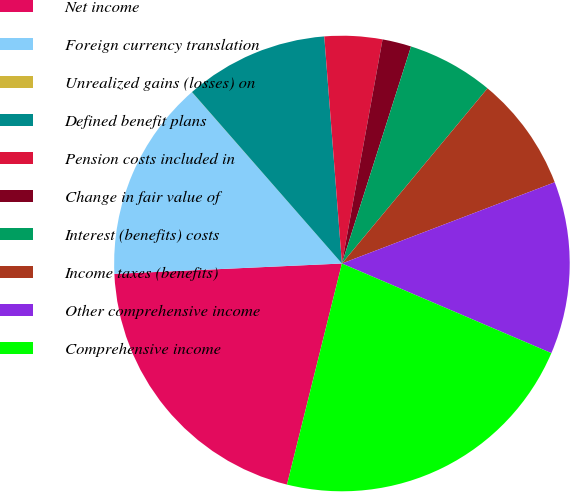<chart> <loc_0><loc_0><loc_500><loc_500><pie_chart><fcel>Net income<fcel>Foreign currency translation<fcel>Unrealized gains (losses) on<fcel>Defined benefit plans<fcel>Pension costs included in<fcel>Change in fair value of<fcel>Interest (benefits) costs<fcel>Income taxes (benefits)<fcel>Other comprehensive income<fcel>Comprehensive income<nl><fcel>20.4%<fcel>14.28%<fcel>0.01%<fcel>10.2%<fcel>4.09%<fcel>2.05%<fcel>6.13%<fcel>8.16%<fcel>12.24%<fcel>22.44%<nl></chart> 